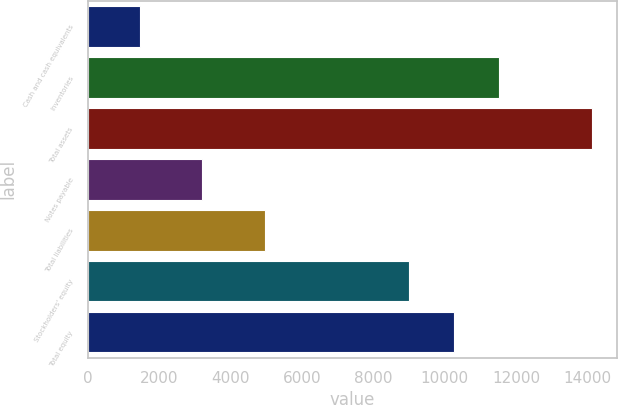Convert chart to OTSL. <chart><loc_0><loc_0><loc_500><loc_500><bar_chart><fcel>Cash and cash equivalents<fcel>Inventories<fcel>Total assets<fcel>Notes payable<fcel>Total liabilities<fcel>Stockholders' equity<fcel>Total equity<nl><fcel>1473.1<fcel>11512.7<fcel>14114.6<fcel>3203.5<fcel>4955.7<fcel>8984.4<fcel>10248.5<nl></chart> 